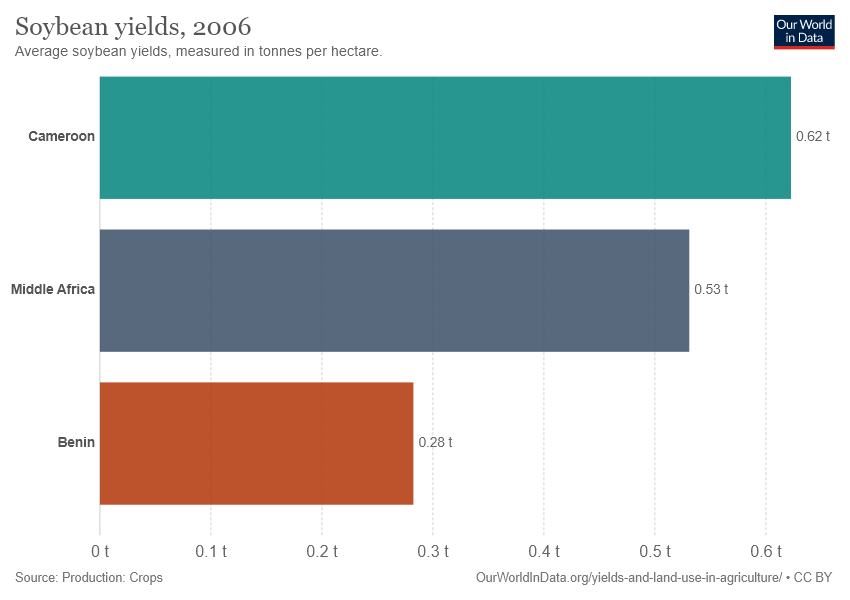List a handful of essential elements in this visual. The soybean yield in Middle Africa is 0.53. The median value of soybean yields among the three countries is 0.53. 